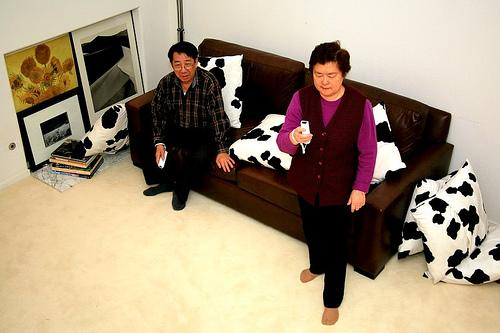Examine the head of the man and describe any unique features on it. The man has black hair and is wearing glasses, making him easily distinguishable. Describe the sitting furniture present in the image and its color. There is a brown leather couch and a brown sofa on a cream carpet in the image. From the image, can you identify the flooring type and color? The flooring appears to be a beige-colored, possibly made of carpet or other soft material. Are both people in the image wearing footwear or barefoot? Both people are barefoot, and the woman has dark pants and bare feet on the beige floor. What kind of controllers are the two people holding, and what colors are they? The man and woman are holding Wii controllers, with the woman's being white and the man's not specified in color. What are the two main activities people are doing in the image? The two main activities are sitting on a brown couch and playing video games while holding game controllers. Count the number of cushions present in the image and describe their position. There are six cushions in the image - three on the couch, two cow-patterned pillows on the floor, and one lying with the picture books and pillow. Mention the objects placed on the floor in the image. Objects on the floor include a black and white photo in a black frame, a stack of books, two cow-patterned pillows, and a picture with books and a pillow. Identify the colors and patterns of the cushions in the scene. The cushions have black and white patterns, including cow patterns on the floor pillows and various black and white designs on the couch pillows. Describe the clothing styles of both the man and woman in the image. The man is wearing a black striped shirt and dark pants, while the woman is wearing a red vest and a purple shirt. Find a pile of colorful magazines that are stacked next to the cushion on the couch, and tell me how many are there. There are no colorful magazines visible in the image. 